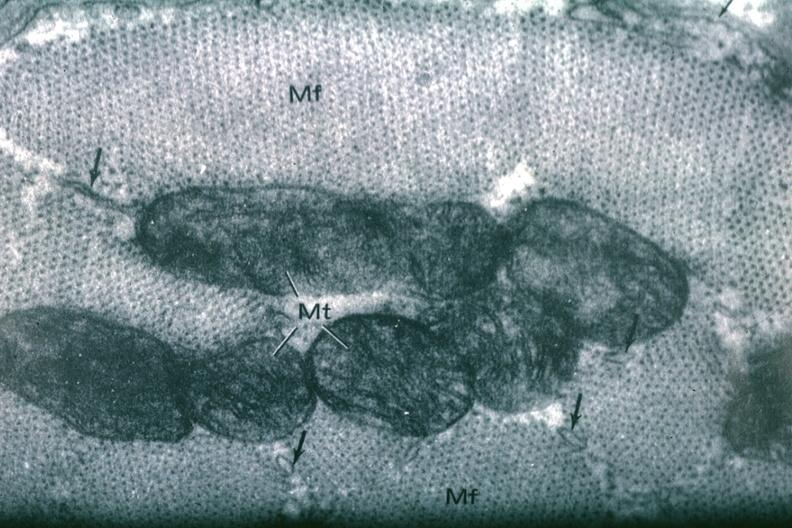where is this area in the body?
Answer the question using a single word or phrase. Heart 